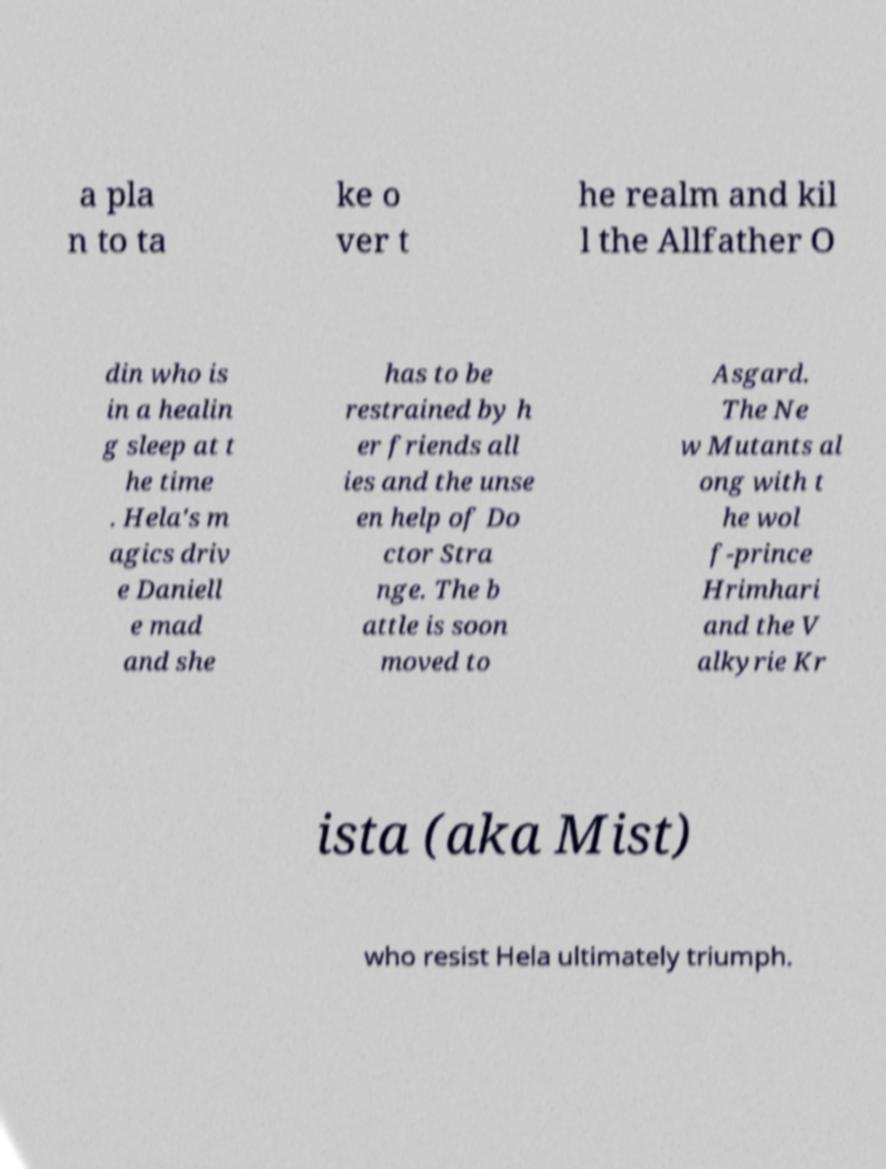Could you extract and type out the text from this image? a pla n to ta ke o ver t he realm and kil l the Allfather O din who is in a healin g sleep at t he time . Hela's m agics driv e Daniell e mad and she has to be restrained by h er friends all ies and the unse en help of Do ctor Stra nge. The b attle is soon moved to Asgard. The Ne w Mutants al ong with t he wol f-prince Hrimhari and the V alkyrie Kr ista (aka Mist) who resist Hela ultimately triumph. 